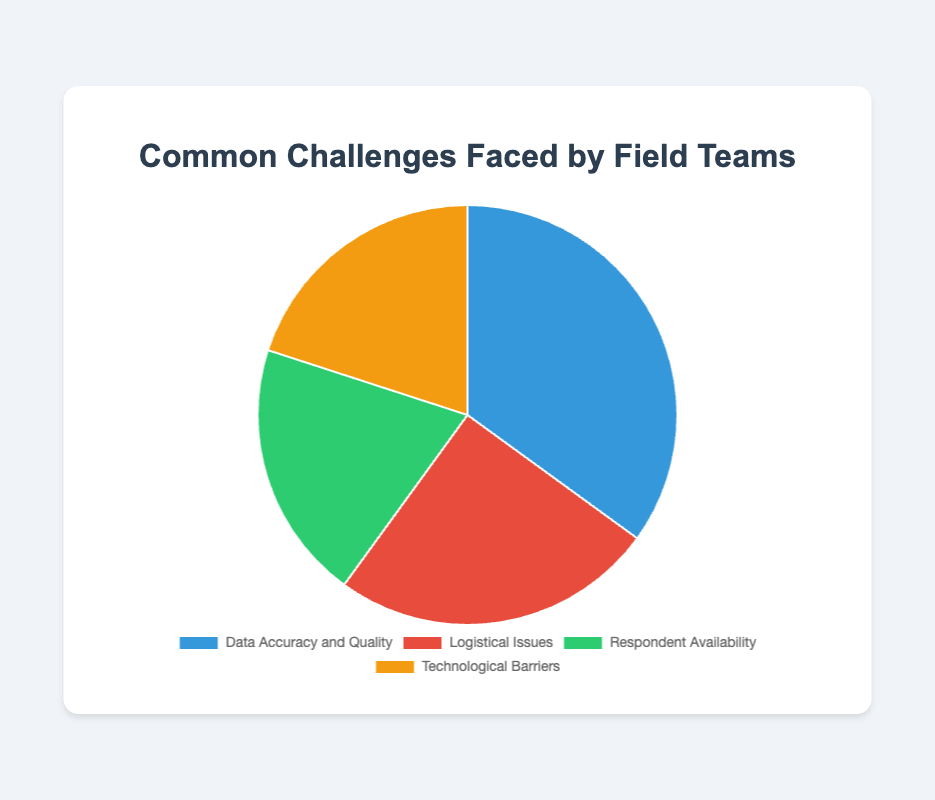What's the largest category in terms of percentage? The largest section of the pie chart represents "Data Accuracy and Quality," which has a percentage of 35.
Answer: Data Accuracy and Quality What's the combined percentage of "Logistical Issues" and "Technological Barriers"? Adding the percentages of "Logistical Issues" (25) and "Technological Barriers" (20) gives a total of 45.
Answer: 45 What's the percentage difference between "Respondent Availability" and "Logistical Issues"? Subtracting the percentage of "Respondent Availability" (20) from "Logistical Issues" (25) gives a difference of 5.
Answer: 5 Which categories are represented equally in the pie chart? Both "Respondent Availability" and "Technological Barriers" are each represented by 20%.
Answer: Respondent Availability and Technological Barriers Ordering the categories from largest to smallest, which one is second? The order from largest to smallest is: Data Accuracy and Quality (35), Logistical Issues (25), Respondent Availability (20), Technological Barriers (20). So, the second one is "Logistical Issues."
Answer: Logistical Issues What's the average percentage of the four challenges? Adding all percentages: 35 (Data Accuracy and Quality) + 25 (Logistical Issues) + 20 (Respondent Availability) + 20 (Technological Barriers) = 100. The average is 100 / 4 = 25.
Answer: 25 How much more does "Data Accuracy and Quality" represent compared to "Technological Barriers"? Subtract the percentage of "Technological Barriers" (20) from "Data Accuracy and Quality" (35), which gives a difference of 15.
Answer: 15 Which slice of the pie chart is colored blue? The slice colored blue represents "Data Accuracy and Quality" as it is the largest section with a percentage of 35.
Answer: Data Accuracy and Quality 